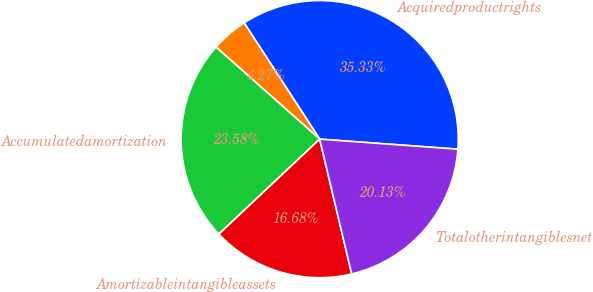Convert chart to OTSL. <chart><loc_0><loc_0><loc_500><loc_500><pie_chart><fcel>Acquiredproductrights<fcel>Unnamed: 1<fcel>Accumulatedamortization<fcel>Amortizableintangibleassets<fcel>Totalotherintangiblesnet<nl><fcel>35.33%<fcel>4.27%<fcel>23.58%<fcel>16.68%<fcel>20.13%<nl></chart> 